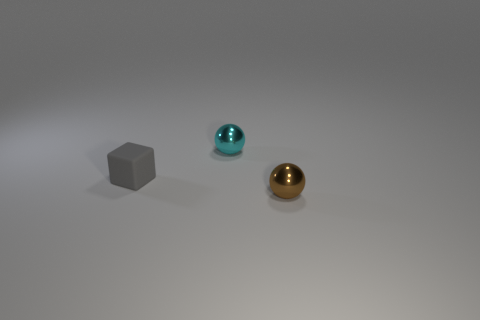There is another metal thing that is the same shape as the cyan shiny object; what color is it? brown 